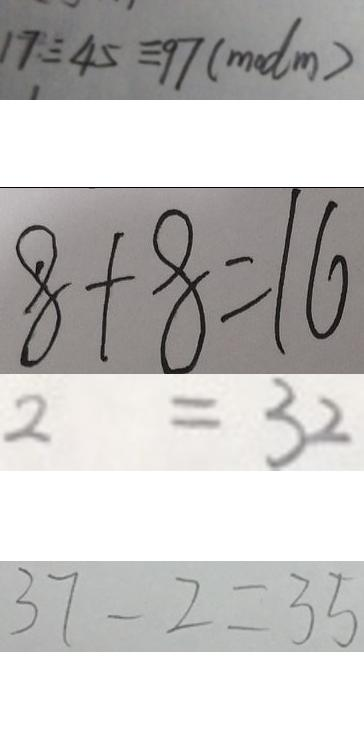Convert formula to latex. <formula><loc_0><loc_0><loc_500><loc_500>1 7 \equiv 4 5 \equiv 9 7 ( m o d m ) 
 8 + 8 = 1 6 
 2 = 3 2 
 3 7 - 2 = 3 5</formula> 